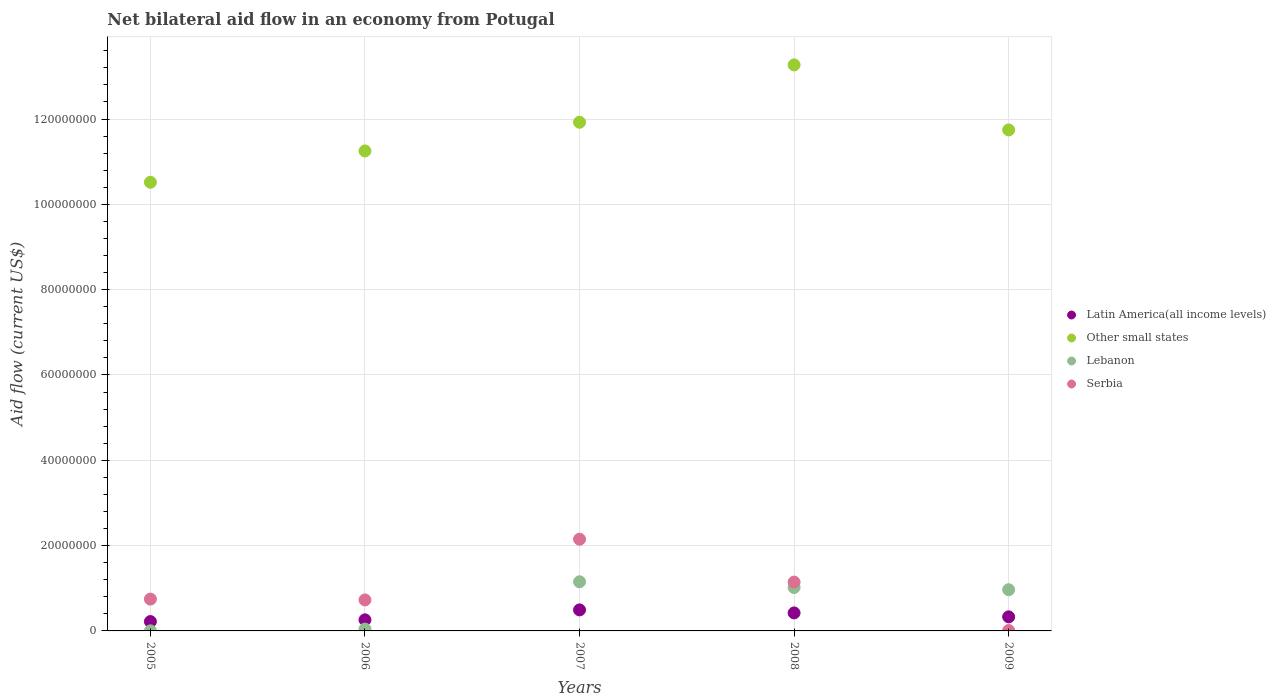How many different coloured dotlines are there?
Give a very brief answer. 4. What is the net bilateral aid flow in Lebanon in 2008?
Keep it short and to the point. 1.02e+07. Across all years, what is the maximum net bilateral aid flow in Other small states?
Make the answer very short. 1.33e+08. Across all years, what is the minimum net bilateral aid flow in Latin America(all income levels)?
Make the answer very short. 2.20e+06. In which year was the net bilateral aid flow in Latin America(all income levels) maximum?
Your answer should be very brief. 2007. What is the total net bilateral aid flow in Latin America(all income levels) in the graph?
Provide a succinct answer. 1.72e+07. What is the difference between the net bilateral aid flow in Latin America(all income levels) in 2005 and that in 2009?
Make the answer very short. -1.10e+06. What is the difference between the net bilateral aid flow in Other small states in 2006 and the net bilateral aid flow in Serbia in 2009?
Give a very brief answer. 1.12e+08. What is the average net bilateral aid flow in Serbia per year?
Make the answer very short. 9.56e+06. In the year 2008, what is the difference between the net bilateral aid flow in Lebanon and net bilateral aid flow in Latin America(all income levels)?
Your answer should be compact. 5.96e+06. In how many years, is the net bilateral aid flow in Lebanon greater than 96000000 US$?
Make the answer very short. 0. What is the ratio of the net bilateral aid flow in Lebanon in 2005 to that in 2006?
Keep it short and to the point. 0.05. Is the difference between the net bilateral aid flow in Lebanon in 2006 and 2007 greater than the difference between the net bilateral aid flow in Latin America(all income levels) in 2006 and 2007?
Offer a very short reply. No. What is the difference between the highest and the second highest net bilateral aid flow in Latin America(all income levels)?
Keep it short and to the point. 7.10e+05. What is the difference between the highest and the lowest net bilateral aid flow in Latin America(all income levels)?
Your response must be concise. 2.73e+06. In how many years, is the net bilateral aid flow in Latin America(all income levels) greater than the average net bilateral aid flow in Latin America(all income levels) taken over all years?
Your answer should be compact. 2. Is it the case that in every year, the sum of the net bilateral aid flow in Lebanon and net bilateral aid flow in Latin America(all income levels)  is greater than the sum of net bilateral aid flow in Other small states and net bilateral aid flow in Serbia?
Your answer should be compact. No. Does the net bilateral aid flow in Other small states monotonically increase over the years?
Offer a terse response. No. Is the net bilateral aid flow in Latin America(all income levels) strictly greater than the net bilateral aid flow in Serbia over the years?
Offer a very short reply. No. How many dotlines are there?
Your answer should be compact. 4. What is the difference between two consecutive major ticks on the Y-axis?
Offer a very short reply. 2.00e+07. Are the values on the major ticks of Y-axis written in scientific E-notation?
Keep it short and to the point. No. Does the graph contain any zero values?
Your answer should be very brief. No. Where does the legend appear in the graph?
Offer a terse response. Center right. How many legend labels are there?
Keep it short and to the point. 4. How are the legend labels stacked?
Provide a short and direct response. Vertical. What is the title of the graph?
Offer a terse response. Net bilateral aid flow in an economy from Potugal. What is the label or title of the X-axis?
Provide a succinct answer. Years. What is the Aid flow (current US$) of Latin America(all income levels) in 2005?
Your answer should be very brief. 2.20e+06. What is the Aid flow (current US$) of Other small states in 2005?
Ensure brevity in your answer.  1.05e+08. What is the Aid flow (current US$) of Lebanon in 2005?
Make the answer very short. 2.00e+04. What is the Aid flow (current US$) in Serbia in 2005?
Your answer should be very brief. 7.46e+06. What is the Aid flow (current US$) of Latin America(all income levels) in 2006?
Offer a terse response. 2.60e+06. What is the Aid flow (current US$) of Other small states in 2006?
Provide a short and direct response. 1.13e+08. What is the Aid flow (current US$) of Lebanon in 2006?
Offer a very short reply. 4.30e+05. What is the Aid flow (current US$) in Serbia in 2006?
Your answer should be very brief. 7.27e+06. What is the Aid flow (current US$) in Latin America(all income levels) in 2007?
Provide a succinct answer. 4.93e+06. What is the Aid flow (current US$) of Other small states in 2007?
Provide a succinct answer. 1.19e+08. What is the Aid flow (current US$) of Lebanon in 2007?
Give a very brief answer. 1.15e+07. What is the Aid flow (current US$) of Serbia in 2007?
Your answer should be very brief. 2.15e+07. What is the Aid flow (current US$) in Latin America(all income levels) in 2008?
Provide a succinct answer. 4.22e+06. What is the Aid flow (current US$) of Other small states in 2008?
Your answer should be very brief. 1.33e+08. What is the Aid flow (current US$) of Lebanon in 2008?
Your response must be concise. 1.02e+07. What is the Aid flow (current US$) in Serbia in 2008?
Offer a very short reply. 1.14e+07. What is the Aid flow (current US$) in Latin America(all income levels) in 2009?
Offer a very short reply. 3.30e+06. What is the Aid flow (current US$) in Other small states in 2009?
Provide a short and direct response. 1.17e+08. What is the Aid flow (current US$) of Lebanon in 2009?
Keep it short and to the point. 9.66e+06. What is the Aid flow (current US$) in Serbia in 2009?
Make the answer very short. 1.00e+05. Across all years, what is the maximum Aid flow (current US$) of Latin America(all income levels)?
Provide a succinct answer. 4.93e+06. Across all years, what is the maximum Aid flow (current US$) of Other small states?
Your answer should be compact. 1.33e+08. Across all years, what is the maximum Aid flow (current US$) in Lebanon?
Give a very brief answer. 1.15e+07. Across all years, what is the maximum Aid flow (current US$) of Serbia?
Ensure brevity in your answer.  2.15e+07. Across all years, what is the minimum Aid flow (current US$) of Latin America(all income levels)?
Offer a terse response. 2.20e+06. Across all years, what is the minimum Aid flow (current US$) of Other small states?
Your response must be concise. 1.05e+08. What is the total Aid flow (current US$) of Latin America(all income levels) in the graph?
Your answer should be very brief. 1.72e+07. What is the total Aid flow (current US$) of Other small states in the graph?
Give a very brief answer. 5.87e+08. What is the total Aid flow (current US$) in Lebanon in the graph?
Offer a terse response. 3.18e+07. What is the total Aid flow (current US$) of Serbia in the graph?
Your response must be concise. 4.78e+07. What is the difference between the Aid flow (current US$) of Latin America(all income levels) in 2005 and that in 2006?
Make the answer very short. -4.00e+05. What is the difference between the Aid flow (current US$) of Other small states in 2005 and that in 2006?
Your response must be concise. -7.34e+06. What is the difference between the Aid flow (current US$) of Lebanon in 2005 and that in 2006?
Offer a very short reply. -4.10e+05. What is the difference between the Aid flow (current US$) of Serbia in 2005 and that in 2006?
Keep it short and to the point. 1.90e+05. What is the difference between the Aid flow (current US$) in Latin America(all income levels) in 2005 and that in 2007?
Provide a short and direct response. -2.73e+06. What is the difference between the Aid flow (current US$) in Other small states in 2005 and that in 2007?
Provide a succinct answer. -1.41e+07. What is the difference between the Aid flow (current US$) in Lebanon in 2005 and that in 2007?
Your answer should be very brief. -1.15e+07. What is the difference between the Aid flow (current US$) of Serbia in 2005 and that in 2007?
Give a very brief answer. -1.40e+07. What is the difference between the Aid flow (current US$) in Latin America(all income levels) in 2005 and that in 2008?
Your answer should be very brief. -2.02e+06. What is the difference between the Aid flow (current US$) in Other small states in 2005 and that in 2008?
Ensure brevity in your answer.  -2.75e+07. What is the difference between the Aid flow (current US$) in Lebanon in 2005 and that in 2008?
Give a very brief answer. -1.02e+07. What is the difference between the Aid flow (current US$) in Serbia in 2005 and that in 2008?
Offer a very short reply. -3.99e+06. What is the difference between the Aid flow (current US$) of Latin America(all income levels) in 2005 and that in 2009?
Offer a terse response. -1.10e+06. What is the difference between the Aid flow (current US$) of Other small states in 2005 and that in 2009?
Provide a succinct answer. -1.23e+07. What is the difference between the Aid flow (current US$) in Lebanon in 2005 and that in 2009?
Keep it short and to the point. -9.64e+06. What is the difference between the Aid flow (current US$) in Serbia in 2005 and that in 2009?
Provide a short and direct response. 7.36e+06. What is the difference between the Aid flow (current US$) in Latin America(all income levels) in 2006 and that in 2007?
Give a very brief answer. -2.33e+06. What is the difference between the Aid flow (current US$) of Other small states in 2006 and that in 2007?
Give a very brief answer. -6.73e+06. What is the difference between the Aid flow (current US$) of Lebanon in 2006 and that in 2007?
Offer a very short reply. -1.11e+07. What is the difference between the Aid flow (current US$) of Serbia in 2006 and that in 2007?
Your answer should be compact. -1.42e+07. What is the difference between the Aid flow (current US$) in Latin America(all income levels) in 2006 and that in 2008?
Offer a very short reply. -1.62e+06. What is the difference between the Aid flow (current US$) in Other small states in 2006 and that in 2008?
Provide a short and direct response. -2.02e+07. What is the difference between the Aid flow (current US$) in Lebanon in 2006 and that in 2008?
Offer a terse response. -9.75e+06. What is the difference between the Aid flow (current US$) of Serbia in 2006 and that in 2008?
Make the answer very short. -4.18e+06. What is the difference between the Aid flow (current US$) in Latin America(all income levels) in 2006 and that in 2009?
Your answer should be compact. -7.00e+05. What is the difference between the Aid flow (current US$) in Other small states in 2006 and that in 2009?
Your answer should be very brief. -4.93e+06. What is the difference between the Aid flow (current US$) in Lebanon in 2006 and that in 2009?
Make the answer very short. -9.23e+06. What is the difference between the Aid flow (current US$) in Serbia in 2006 and that in 2009?
Offer a terse response. 7.17e+06. What is the difference between the Aid flow (current US$) of Latin America(all income levels) in 2007 and that in 2008?
Keep it short and to the point. 7.10e+05. What is the difference between the Aid flow (current US$) in Other small states in 2007 and that in 2008?
Your response must be concise. -1.34e+07. What is the difference between the Aid flow (current US$) in Lebanon in 2007 and that in 2008?
Make the answer very short. 1.34e+06. What is the difference between the Aid flow (current US$) of Serbia in 2007 and that in 2008?
Your answer should be compact. 1.00e+07. What is the difference between the Aid flow (current US$) of Latin America(all income levels) in 2007 and that in 2009?
Your response must be concise. 1.63e+06. What is the difference between the Aid flow (current US$) in Other small states in 2007 and that in 2009?
Give a very brief answer. 1.80e+06. What is the difference between the Aid flow (current US$) of Lebanon in 2007 and that in 2009?
Offer a very short reply. 1.86e+06. What is the difference between the Aid flow (current US$) of Serbia in 2007 and that in 2009?
Offer a very short reply. 2.14e+07. What is the difference between the Aid flow (current US$) in Latin America(all income levels) in 2008 and that in 2009?
Your answer should be compact. 9.20e+05. What is the difference between the Aid flow (current US$) of Other small states in 2008 and that in 2009?
Provide a short and direct response. 1.52e+07. What is the difference between the Aid flow (current US$) in Lebanon in 2008 and that in 2009?
Offer a very short reply. 5.20e+05. What is the difference between the Aid flow (current US$) in Serbia in 2008 and that in 2009?
Provide a succinct answer. 1.14e+07. What is the difference between the Aid flow (current US$) of Latin America(all income levels) in 2005 and the Aid flow (current US$) of Other small states in 2006?
Make the answer very short. -1.10e+08. What is the difference between the Aid flow (current US$) in Latin America(all income levels) in 2005 and the Aid flow (current US$) in Lebanon in 2006?
Ensure brevity in your answer.  1.77e+06. What is the difference between the Aid flow (current US$) of Latin America(all income levels) in 2005 and the Aid flow (current US$) of Serbia in 2006?
Provide a short and direct response. -5.07e+06. What is the difference between the Aid flow (current US$) in Other small states in 2005 and the Aid flow (current US$) in Lebanon in 2006?
Your response must be concise. 1.05e+08. What is the difference between the Aid flow (current US$) in Other small states in 2005 and the Aid flow (current US$) in Serbia in 2006?
Make the answer very short. 9.79e+07. What is the difference between the Aid flow (current US$) in Lebanon in 2005 and the Aid flow (current US$) in Serbia in 2006?
Make the answer very short. -7.25e+06. What is the difference between the Aid flow (current US$) of Latin America(all income levels) in 2005 and the Aid flow (current US$) of Other small states in 2007?
Your answer should be very brief. -1.17e+08. What is the difference between the Aid flow (current US$) of Latin America(all income levels) in 2005 and the Aid flow (current US$) of Lebanon in 2007?
Your response must be concise. -9.32e+06. What is the difference between the Aid flow (current US$) in Latin America(all income levels) in 2005 and the Aid flow (current US$) in Serbia in 2007?
Provide a succinct answer. -1.93e+07. What is the difference between the Aid flow (current US$) in Other small states in 2005 and the Aid flow (current US$) in Lebanon in 2007?
Make the answer very short. 9.37e+07. What is the difference between the Aid flow (current US$) of Other small states in 2005 and the Aid flow (current US$) of Serbia in 2007?
Your answer should be very brief. 8.37e+07. What is the difference between the Aid flow (current US$) in Lebanon in 2005 and the Aid flow (current US$) in Serbia in 2007?
Your answer should be very brief. -2.15e+07. What is the difference between the Aid flow (current US$) in Latin America(all income levels) in 2005 and the Aid flow (current US$) in Other small states in 2008?
Keep it short and to the point. -1.30e+08. What is the difference between the Aid flow (current US$) in Latin America(all income levels) in 2005 and the Aid flow (current US$) in Lebanon in 2008?
Your answer should be very brief. -7.98e+06. What is the difference between the Aid flow (current US$) in Latin America(all income levels) in 2005 and the Aid flow (current US$) in Serbia in 2008?
Give a very brief answer. -9.25e+06. What is the difference between the Aid flow (current US$) of Other small states in 2005 and the Aid flow (current US$) of Lebanon in 2008?
Ensure brevity in your answer.  9.50e+07. What is the difference between the Aid flow (current US$) in Other small states in 2005 and the Aid flow (current US$) in Serbia in 2008?
Give a very brief answer. 9.37e+07. What is the difference between the Aid flow (current US$) in Lebanon in 2005 and the Aid flow (current US$) in Serbia in 2008?
Keep it short and to the point. -1.14e+07. What is the difference between the Aid flow (current US$) in Latin America(all income levels) in 2005 and the Aid flow (current US$) in Other small states in 2009?
Your answer should be compact. -1.15e+08. What is the difference between the Aid flow (current US$) in Latin America(all income levels) in 2005 and the Aid flow (current US$) in Lebanon in 2009?
Offer a terse response. -7.46e+06. What is the difference between the Aid flow (current US$) of Latin America(all income levels) in 2005 and the Aid flow (current US$) of Serbia in 2009?
Provide a short and direct response. 2.10e+06. What is the difference between the Aid flow (current US$) of Other small states in 2005 and the Aid flow (current US$) of Lebanon in 2009?
Keep it short and to the point. 9.55e+07. What is the difference between the Aid flow (current US$) in Other small states in 2005 and the Aid flow (current US$) in Serbia in 2009?
Provide a succinct answer. 1.05e+08. What is the difference between the Aid flow (current US$) in Latin America(all income levels) in 2006 and the Aid flow (current US$) in Other small states in 2007?
Ensure brevity in your answer.  -1.17e+08. What is the difference between the Aid flow (current US$) in Latin America(all income levels) in 2006 and the Aid flow (current US$) in Lebanon in 2007?
Your response must be concise. -8.92e+06. What is the difference between the Aid flow (current US$) of Latin America(all income levels) in 2006 and the Aid flow (current US$) of Serbia in 2007?
Keep it short and to the point. -1.89e+07. What is the difference between the Aid flow (current US$) of Other small states in 2006 and the Aid flow (current US$) of Lebanon in 2007?
Your answer should be very brief. 1.01e+08. What is the difference between the Aid flow (current US$) of Other small states in 2006 and the Aid flow (current US$) of Serbia in 2007?
Provide a short and direct response. 9.10e+07. What is the difference between the Aid flow (current US$) of Lebanon in 2006 and the Aid flow (current US$) of Serbia in 2007?
Give a very brief answer. -2.11e+07. What is the difference between the Aid flow (current US$) in Latin America(all income levels) in 2006 and the Aid flow (current US$) in Other small states in 2008?
Offer a terse response. -1.30e+08. What is the difference between the Aid flow (current US$) of Latin America(all income levels) in 2006 and the Aid flow (current US$) of Lebanon in 2008?
Provide a short and direct response. -7.58e+06. What is the difference between the Aid flow (current US$) of Latin America(all income levels) in 2006 and the Aid flow (current US$) of Serbia in 2008?
Your response must be concise. -8.85e+06. What is the difference between the Aid flow (current US$) in Other small states in 2006 and the Aid flow (current US$) in Lebanon in 2008?
Ensure brevity in your answer.  1.02e+08. What is the difference between the Aid flow (current US$) in Other small states in 2006 and the Aid flow (current US$) in Serbia in 2008?
Offer a very short reply. 1.01e+08. What is the difference between the Aid flow (current US$) in Lebanon in 2006 and the Aid flow (current US$) in Serbia in 2008?
Make the answer very short. -1.10e+07. What is the difference between the Aid flow (current US$) of Latin America(all income levels) in 2006 and the Aid flow (current US$) of Other small states in 2009?
Ensure brevity in your answer.  -1.15e+08. What is the difference between the Aid flow (current US$) in Latin America(all income levels) in 2006 and the Aid flow (current US$) in Lebanon in 2009?
Provide a succinct answer. -7.06e+06. What is the difference between the Aid flow (current US$) in Latin America(all income levels) in 2006 and the Aid flow (current US$) in Serbia in 2009?
Keep it short and to the point. 2.50e+06. What is the difference between the Aid flow (current US$) in Other small states in 2006 and the Aid flow (current US$) in Lebanon in 2009?
Keep it short and to the point. 1.03e+08. What is the difference between the Aid flow (current US$) of Other small states in 2006 and the Aid flow (current US$) of Serbia in 2009?
Ensure brevity in your answer.  1.12e+08. What is the difference between the Aid flow (current US$) of Latin America(all income levels) in 2007 and the Aid flow (current US$) of Other small states in 2008?
Give a very brief answer. -1.28e+08. What is the difference between the Aid flow (current US$) in Latin America(all income levels) in 2007 and the Aid flow (current US$) in Lebanon in 2008?
Give a very brief answer. -5.25e+06. What is the difference between the Aid flow (current US$) in Latin America(all income levels) in 2007 and the Aid flow (current US$) in Serbia in 2008?
Ensure brevity in your answer.  -6.52e+06. What is the difference between the Aid flow (current US$) in Other small states in 2007 and the Aid flow (current US$) in Lebanon in 2008?
Ensure brevity in your answer.  1.09e+08. What is the difference between the Aid flow (current US$) of Other small states in 2007 and the Aid flow (current US$) of Serbia in 2008?
Give a very brief answer. 1.08e+08. What is the difference between the Aid flow (current US$) of Lebanon in 2007 and the Aid flow (current US$) of Serbia in 2008?
Your response must be concise. 7.00e+04. What is the difference between the Aid flow (current US$) in Latin America(all income levels) in 2007 and the Aid flow (current US$) in Other small states in 2009?
Your answer should be compact. -1.13e+08. What is the difference between the Aid flow (current US$) of Latin America(all income levels) in 2007 and the Aid flow (current US$) of Lebanon in 2009?
Provide a succinct answer. -4.73e+06. What is the difference between the Aid flow (current US$) in Latin America(all income levels) in 2007 and the Aid flow (current US$) in Serbia in 2009?
Provide a short and direct response. 4.83e+06. What is the difference between the Aid flow (current US$) of Other small states in 2007 and the Aid flow (current US$) of Lebanon in 2009?
Offer a terse response. 1.10e+08. What is the difference between the Aid flow (current US$) in Other small states in 2007 and the Aid flow (current US$) in Serbia in 2009?
Your response must be concise. 1.19e+08. What is the difference between the Aid flow (current US$) of Lebanon in 2007 and the Aid flow (current US$) of Serbia in 2009?
Ensure brevity in your answer.  1.14e+07. What is the difference between the Aid flow (current US$) in Latin America(all income levels) in 2008 and the Aid flow (current US$) in Other small states in 2009?
Provide a short and direct response. -1.13e+08. What is the difference between the Aid flow (current US$) of Latin America(all income levels) in 2008 and the Aid flow (current US$) of Lebanon in 2009?
Offer a terse response. -5.44e+06. What is the difference between the Aid flow (current US$) in Latin America(all income levels) in 2008 and the Aid flow (current US$) in Serbia in 2009?
Provide a succinct answer. 4.12e+06. What is the difference between the Aid flow (current US$) in Other small states in 2008 and the Aid flow (current US$) in Lebanon in 2009?
Provide a short and direct response. 1.23e+08. What is the difference between the Aid flow (current US$) in Other small states in 2008 and the Aid flow (current US$) in Serbia in 2009?
Provide a short and direct response. 1.33e+08. What is the difference between the Aid flow (current US$) of Lebanon in 2008 and the Aid flow (current US$) of Serbia in 2009?
Your answer should be compact. 1.01e+07. What is the average Aid flow (current US$) of Latin America(all income levels) per year?
Keep it short and to the point. 3.45e+06. What is the average Aid flow (current US$) of Other small states per year?
Your answer should be compact. 1.17e+08. What is the average Aid flow (current US$) in Lebanon per year?
Ensure brevity in your answer.  6.36e+06. What is the average Aid flow (current US$) in Serbia per year?
Your answer should be very brief. 9.56e+06. In the year 2005, what is the difference between the Aid flow (current US$) in Latin America(all income levels) and Aid flow (current US$) in Other small states?
Provide a succinct answer. -1.03e+08. In the year 2005, what is the difference between the Aid flow (current US$) of Latin America(all income levels) and Aid flow (current US$) of Lebanon?
Offer a terse response. 2.18e+06. In the year 2005, what is the difference between the Aid flow (current US$) in Latin America(all income levels) and Aid flow (current US$) in Serbia?
Your answer should be compact. -5.26e+06. In the year 2005, what is the difference between the Aid flow (current US$) in Other small states and Aid flow (current US$) in Lebanon?
Your answer should be compact. 1.05e+08. In the year 2005, what is the difference between the Aid flow (current US$) of Other small states and Aid flow (current US$) of Serbia?
Provide a succinct answer. 9.77e+07. In the year 2005, what is the difference between the Aid flow (current US$) of Lebanon and Aid flow (current US$) of Serbia?
Offer a very short reply. -7.44e+06. In the year 2006, what is the difference between the Aid flow (current US$) in Latin America(all income levels) and Aid flow (current US$) in Other small states?
Your answer should be very brief. -1.10e+08. In the year 2006, what is the difference between the Aid flow (current US$) of Latin America(all income levels) and Aid flow (current US$) of Lebanon?
Your answer should be compact. 2.17e+06. In the year 2006, what is the difference between the Aid flow (current US$) in Latin America(all income levels) and Aid flow (current US$) in Serbia?
Your response must be concise. -4.67e+06. In the year 2006, what is the difference between the Aid flow (current US$) in Other small states and Aid flow (current US$) in Lebanon?
Ensure brevity in your answer.  1.12e+08. In the year 2006, what is the difference between the Aid flow (current US$) in Other small states and Aid flow (current US$) in Serbia?
Your answer should be very brief. 1.05e+08. In the year 2006, what is the difference between the Aid flow (current US$) of Lebanon and Aid flow (current US$) of Serbia?
Your answer should be compact. -6.84e+06. In the year 2007, what is the difference between the Aid flow (current US$) in Latin America(all income levels) and Aid flow (current US$) in Other small states?
Provide a short and direct response. -1.14e+08. In the year 2007, what is the difference between the Aid flow (current US$) of Latin America(all income levels) and Aid flow (current US$) of Lebanon?
Your answer should be compact. -6.59e+06. In the year 2007, what is the difference between the Aid flow (current US$) of Latin America(all income levels) and Aid flow (current US$) of Serbia?
Keep it short and to the point. -1.66e+07. In the year 2007, what is the difference between the Aid flow (current US$) of Other small states and Aid flow (current US$) of Lebanon?
Offer a terse response. 1.08e+08. In the year 2007, what is the difference between the Aid flow (current US$) of Other small states and Aid flow (current US$) of Serbia?
Your response must be concise. 9.78e+07. In the year 2007, what is the difference between the Aid flow (current US$) of Lebanon and Aid flow (current US$) of Serbia?
Your answer should be compact. -9.98e+06. In the year 2008, what is the difference between the Aid flow (current US$) in Latin America(all income levels) and Aid flow (current US$) in Other small states?
Your answer should be very brief. -1.28e+08. In the year 2008, what is the difference between the Aid flow (current US$) of Latin America(all income levels) and Aid flow (current US$) of Lebanon?
Provide a short and direct response. -5.96e+06. In the year 2008, what is the difference between the Aid flow (current US$) in Latin America(all income levels) and Aid flow (current US$) in Serbia?
Your answer should be very brief. -7.23e+06. In the year 2008, what is the difference between the Aid flow (current US$) in Other small states and Aid flow (current US$) in Lebanon?
Ensure brevity in your answer.  1.23e+08. In the year 2008, what is the difference between the Aid flow (current US$) in Other small states and Aid flow (current US$) in Serbia?
Provide a short and direct response. 1.21e+08. In the year 2008, what is the difference between the Aid flow (current US$) in Lebanon and Aid flow (current US$) in Serbia?
Your answer should be very brief. -1.27e+06. In the year 2009, what is the difference between the Aid flow (current US$) in Latin America(all income levels) and Aid flow (current US$) in Other small states?
Keep it short and to the point. -1.14e+08. In the year 2009, what is the difference between the Aid flow (current US$) of Latin America(all income levels) and Aid flow (current US$) of Lebanon?
Your answer should be very brief. -6.36e+06. In the year 2009, what is the difference between the Aid flow (current US$) in Latin America(all income levels) and Aid flow (current US$) in Serbia?
Provide a succinct answer. 3.20e+06. In the year 2009, what is the difference between the Aid flow (current US$) in Other small states and Aid flow (current US$) in Lebanon?
Your response must be concise. 1.08e+08. In the year 2009, what is the difference between the Aid flow (current US$) in Other small states and Aid flow (current US$) in Serbia?
Ensure brevity in your answer.  1.17e+08. In the year 2009, what is the difference between the Aid flow (current US$) in Lebanon and Aid flow (current US$) in Serbia?
Provide a short and direct response. 9.56e+06. What is the ratio of the Aid flow (current US$) of Latin America(all income levels) in 2005 to that in 2006?
Offer a very short reply. 0.85. What is the ratio of the Aid flow (current US$) of Other small states in 2005 to that in 2006?
Provide a succinct answer. 0.93. What is the ratio of the Aid flow (current US$) of Lebanon in 2005 to that in 2006?
Keep it short and to the point. 0.05. What is the ratio of the Aid flow (current US$) of Serbia in 2005 to that in 2006?
Keep it short and to the point. 1.03. What is the ratio of the Aid flow (current US$) in Latin America(all income levels) in 2005 to that in 2007?
Ensure brevity in your answer.  0.45. What is the ratio of the Aid flow (current US$) in Other small states in 2005 to that in 2007?
Your answer should be very brief. 0.88. What is the ratio of the Aid flow (current US$) in Lebanon in 2005 to that in 2007?
Make the answer very short. 0. What is the ratio of the Aid flow (current US$) in Serbia in 2005 to that in 2007?
Provide a succinct answer. 0.35. What is the ratio of the Aid flow (current US$) in Latin America(all income levels) in 2005 to that in 2008?
Your response must be concise. 0.52. What is the ratio of the Aid flow (current US$) in Other small states in 2005 to that in 2008?
Give a very brief answer. 0.79. What is the ratio of the Aid flow (current US$) in Lebanon in 2005 to that in 2008?
Ensure brevity in your answer.  0. What is the ratio of the Aid flow (current US$) in Serbia in 2005 to that in 2008?
Your answer should be very brief. 0.65. What is the ratio of the Aid flow (current US$) of Other small states in 2005 to that in 2009?
Provide a short and direct response. 0.9. What is the ratio of the Aid flow (current US$) in Lebanon in 2005 to that in 2009?
Give a very brief answer. 0. What is the ratio of the Aid flow (current US$) in Serbia in 2005 to that in 2009?
Keep it short and to the point. 74.6. What is the ratio of the Aid flow (current US$) in Latin America(all income levels) in 2006 to that in 2007?
Your answer should be very brief. 0.53. What is the ratio of the Aid flow (current US$) in Other small states in 2006 to that in 2007?
Ensure brevity in your answer.  0.94. What is the ratio of the Aid flow (current US$) of Lebanon in 2006 to that in 2007?
Provide a short and direct response. 0.04. What is the ratio of the Aid flow (current US$) of Serbia in 2006 to that in 2007?
Ensure brevity in your answer.  0.34. What is the ratio of the Aid flow (current US$) in Latin America(all income levels) in 2006 to that in 2008?
Provide a succinct answer. 0.62. What is the ratio of the Aid flow (current US$) in Other small states in 2006 to that in 2008?
Offer a very short reply. 0.85. What is the ratio of the Aid flow (current US$) of Lebanon in 2006 to that in 2008?
Offer a terse response. 0.04. What is the ratio of the Aid flow (current US$) of Serbia in 2006 to that in 2008?
Your answer should be compact. 0.63. What is the ratio of the Aid flow (current US$) of Latin America(all income levels) in 2006 to that in 2009?
Your response must be concise. 0.79. What is the ratio of the Aid flow (current US$) in Other small states in 2006 to that in 2009?
Ensure brevity in your answer.  0.96. What is the ratio of the Aid flow (current US$) in Lebanon in 2006 to that in 2009?
Your answer should be very brief. 0.04. What is the ratio of the Aid flow (current US$) in Serbia in 2006 to that in 2009?
Your response must be concise. 72.7. What is the ratio of the Aid flow (current US$) in Latin America(all income levels) in 2007 to that in 2008?
Ensure brevity in your answer.  1.17. What is the ratio of the Aid flow (current US$) in Other small states in 2007 to that in 2008?
Your answer should be very brief. 0.9. What is the ratio of the Aid flow (current US$) in Lebanon in 2007 to that in 2008?
Make the answer very short. 1.13. What is the ratio of the Aid flow (current US$) of Serbia in 2007 to that in 2008?
Offer a very short reply. 1.88. What is the ratio of the Aid flow (current US$) in Latin America(all income levels) in 2007 to that in 2009?
Your response must be concise. 1.49. What is the ratio of the Aid flow (current US$) in Other small states in 2007 to that in 2009?
Your answer should be compact. 1.02. What is the ratio of the Aid flow (current US$) of Lebanon in 2007 to that in 2009?
Your response must be concise. 1.19. What is the ratio of the Aid flow (current US$) of Serbia in 2007 to that in 2009?
Offer a very short reply. 215. What is the ratio of the Aid flow (current US$) of Latin America(all income levels) in 2008 to that in 2009?
Provide a succinct answer. 1.28. What is the ratio of the Aid flow (current US$) in Other small states in 2008 to that in 2009?
Provide a short and direct response. 1.13. What is the ratio of the Aid flow (current US$) in Lebanon in 2008 to that in 2009?
Ensure brevity in your answer.  1.05. What is the ratio of the Aid flow (current US$) of Serbia in 2008 to that in 2009?
Provide a short and direct response. 114.5. What is the difference between the highest and the second highest Aid flow (current US$) in Latin America(all income levels)?
Provide a succinct answer. 7.10e+05. What is the difference between the highest and the second highest Aid flow (current US$) in Other small states?
Ensure brevity in your answer.  1.34e+07. What is the difference between the highest and the second highest Aid flow (current US$) of Lebanon?
Give a very brief answer. 1.34e+06. What is the difference between the highest and the second highest Aid flow (current US$) of Serbia?
Provide a short and direct response. 1.00e+07. What is the difference between the highest and the lowest Aid flow (current US$) in Latin America(all income levels)?
Ensure brevity in your answer.  2.73e+06. What is the difference between the highest and the lowest Aid flow (current US$) in Other small states?
Ensure brevity in your answer.  2.75e+07. What is the difference between the highest and the lowest Aid flow (current US$) in Lebanon?
Offer a terse response. 1.15e+07. What is the difference between the highest and the lowest Aid flow (current US$) of Serbia?
Give a very brief answer. 2.14e+07. 